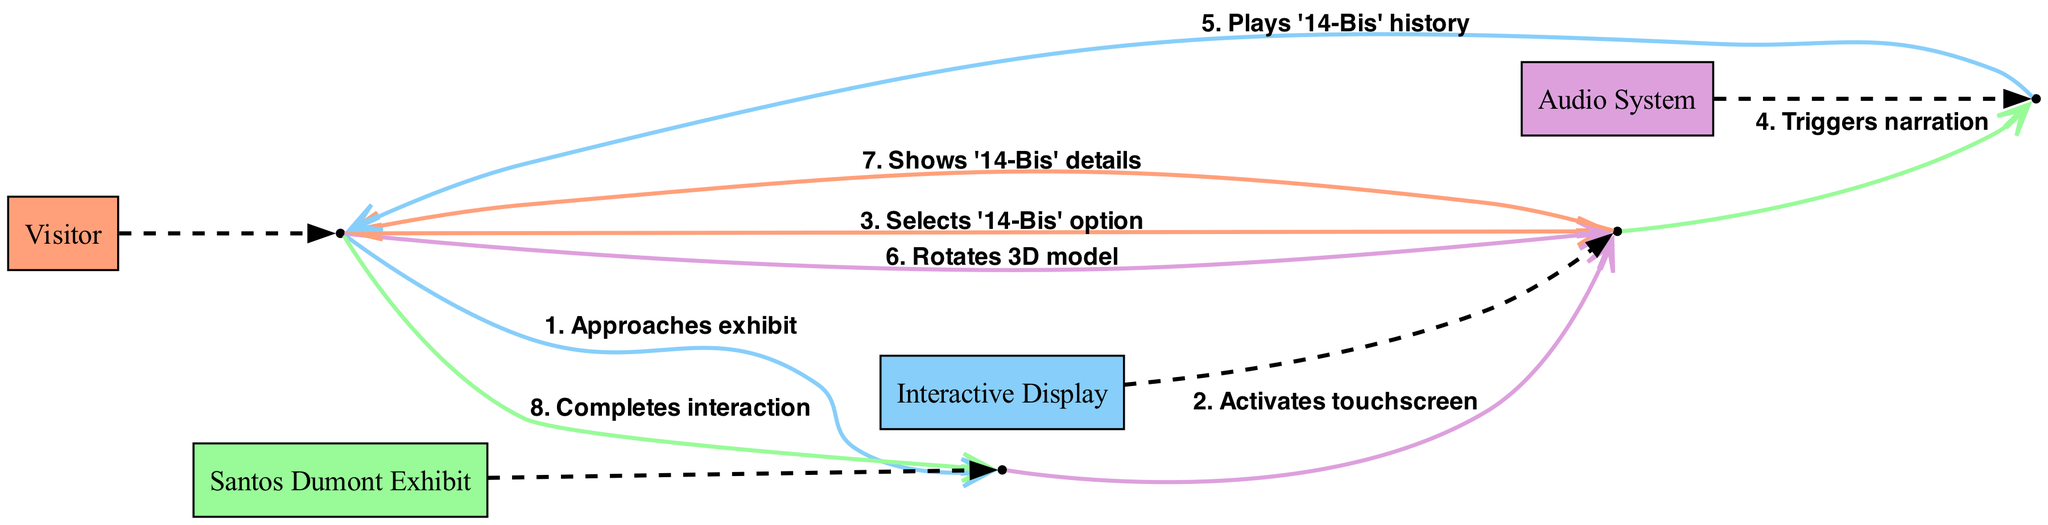What is the first action in the sequence? The sequence starts with the Visitor approaching the Santos Dumont Exhibit. This is the initial step of the interaction process shown in the diagram.
Answer: Approaches exhibit Who activates the touchscreen? The Santos Dumont Exhibit activates the Interactive Display's touchscreen following the Visitor's approach. This relationship shows that the exhibit controls the display after initial visitor interaction.
Answer: Activates touchscreen How many actors are involved in the interaction? There are four actors: Visitor, Santos Dumont Exhibit, Interactive Display, and Audio System. They represent different roles in the interaction process shown in the diagram.
Answer: Four What option does the Visitor select on the Interactive Display? The Visitor selects the '14-Bis' option on the Interactive Display, demonstrating the Visitor's engagement with the content related to Santos Dumont's work.
Answer: '14-Bis' option What does the Audio System do after the Interactive Display is triggered? After being triggered by the Interactive Display, the Audio System plays the history of the '14-Bis'. This illustrates how the system provides auditory information to complement the visual display.
Answer: Plays '14-Bis' history What action follows the Visitor's selection of the '14-Bis' option? After selecting the '14-Bis' option, the Visitor rotates the 3D model on the Interactive Display. This interaction indicates the Visitor's exploration of the exhibit’s content in a more interactive way.
Answer: Rotates 3D model What is the last action taken by the Visitor? The last action taken by the Visitor in the sequence is completing the interaction with the Santos Dumont Exhibit. This signifies the end of their engagement with the exhibit as shown in the diagram.
Answer: Completes interaction Which system shows details about the '14-Bis'? After the Visitor rotates the 3D model, the Interactive Display shows details about the '14-Bis'. This step reveals how the display provides further context and information to the Visitor's interest.
Answer: Shows '14-Bis' details 